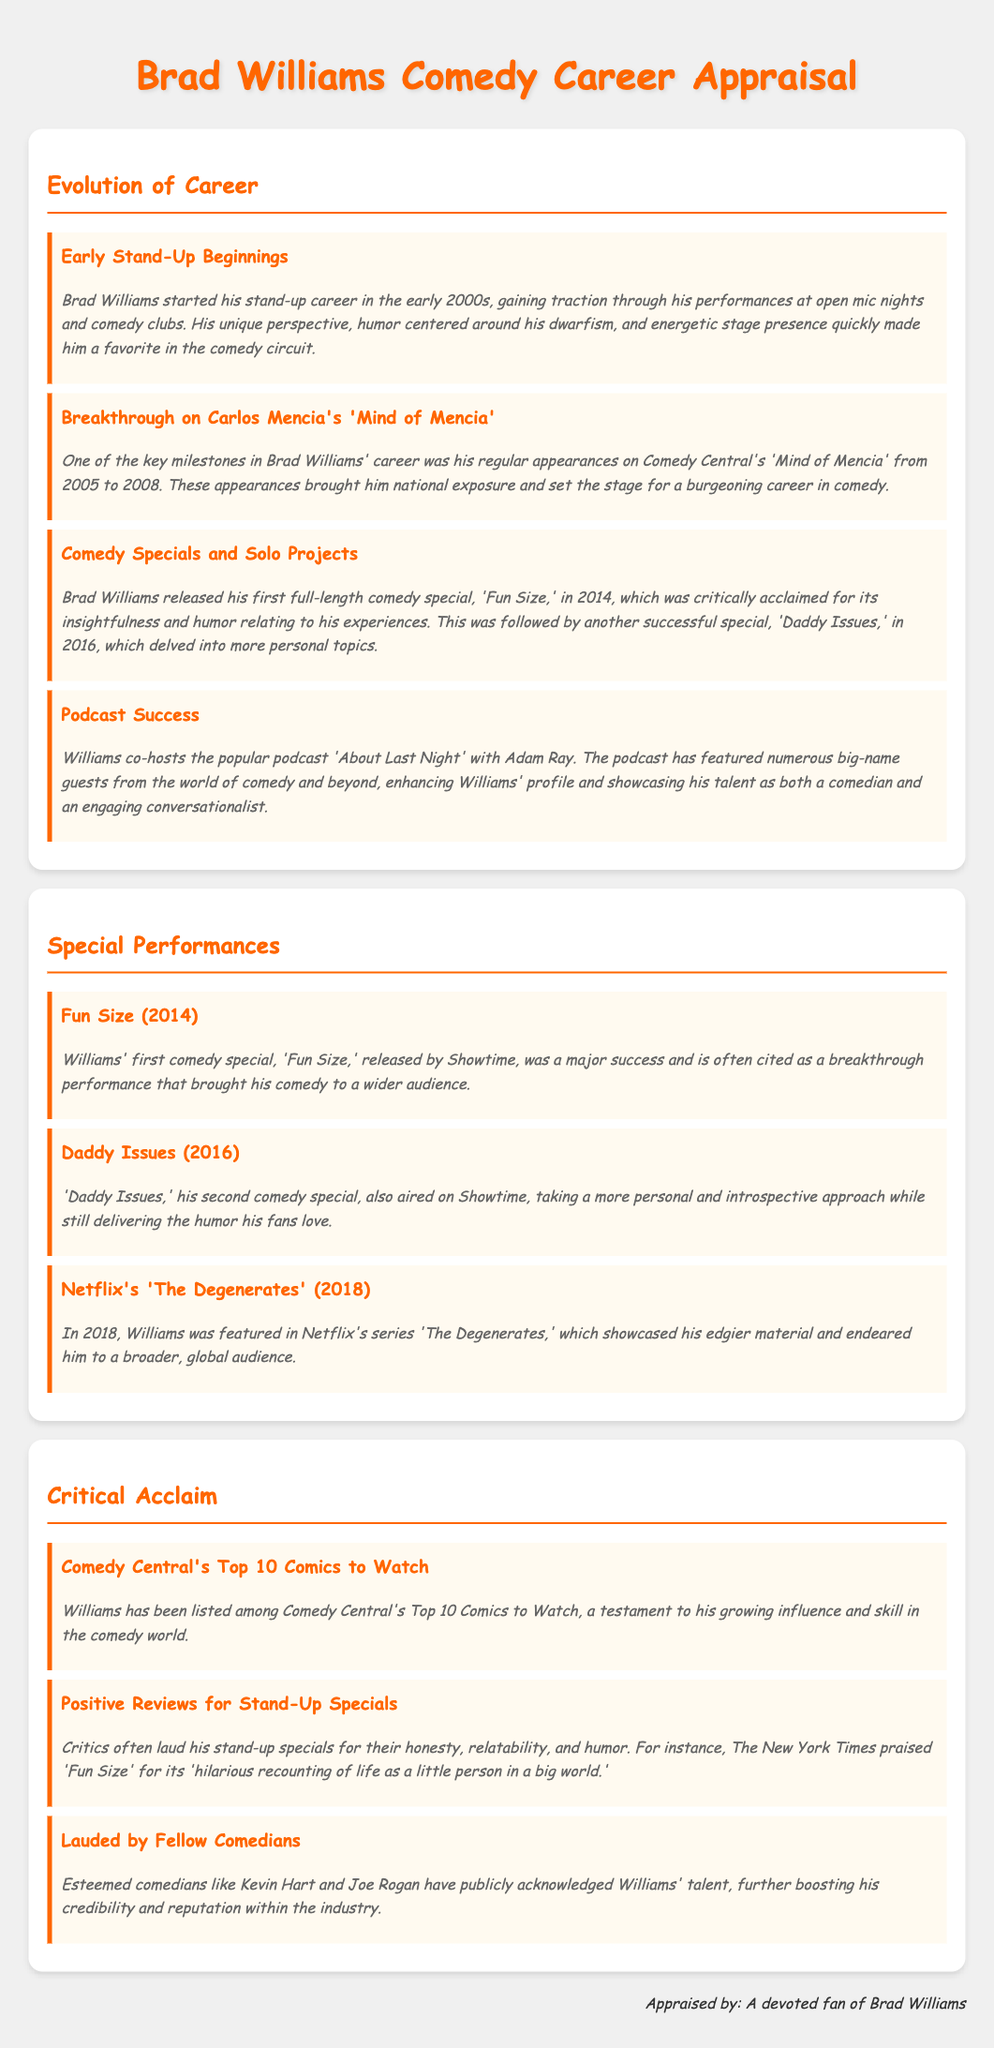What year did Brad Williams release 'Fun Size'? 'Fun Size' was released in 2014, as stated in the document.
Answer: 2014 What is the title of Brad Williams' second comedy special? The document mentions that his second comedy special is titled 'Daddy Issues.'
Answer: Daddy Issues Which show featured Brad Williams from 2005 to 2008? The document specifies that he appeared on 'Mind of Mencia' during those years.
Answer: Mind of Mencia Who is Brad Williams' co-host on the podcast 'About Last Night'? The document states that Adam Ray is his co-host on the podcast.
Answer: Adam Ray Which accolade did Brad Williams receive related to Comedy Central? The document indicates he was listed among Comedy Central's Top 10 Comics to Watch.
Answer: Top 10 Comics to Watch What was a significant factor in Williams' early success? The document cites his unique perspective and energetic stage presence as major factors in his early success.
Answer: Unique perspective and energetic stage presence What type of humor does Brad Williams often focus on in his performances? The document mentions that he focuses on humor relating to his experiences with dwarfism.
Answer: Dwarfism Which esteemed comedians have acknowledged Brad Williams' talent? The document refers to Kevin Hart and Joe Rogan as comedians who have publicly recognized his talent.
Answer: Kevin Hart and Joe Rogan What year was 'Daddy Issues' released? According to the document, 'Daddy Issues' was released in 2016.
Answer: 2016 